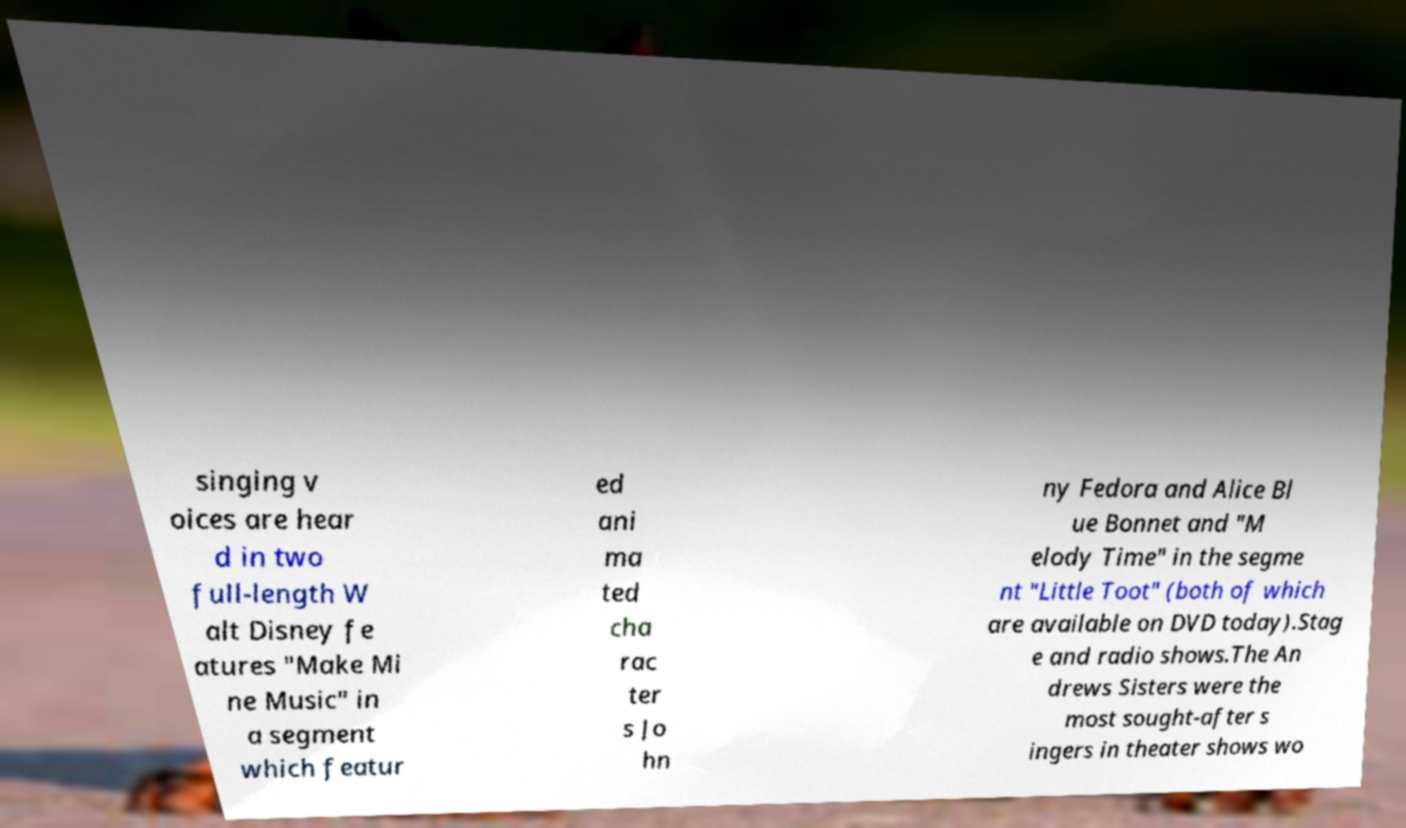For documentation purposes, I need the text within this image transcribed. Could you provide that? singing v oices are hear d in two full-length W alt Disney fe atures "Make Mi ne Music" in a segment which featur ed ani ma ted cha rac ter s Jo hn ny Fedora and Alice Bl ue Bonnet and "M elody Time" in the segme nt "Little Toot" (both of which are available on DVD today).Stag e and radio shows.The An drews Sisters were the most sought-after s ingers in theater shows wo 